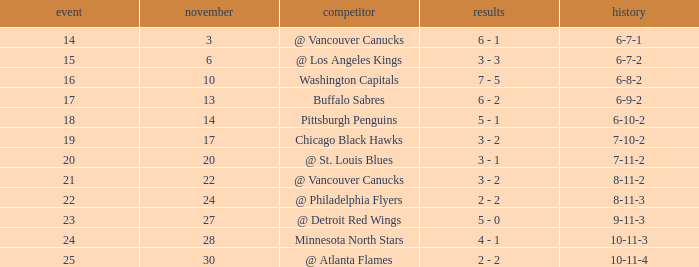Who is the opponent on november 24? @ Philadelphia Flyers. 